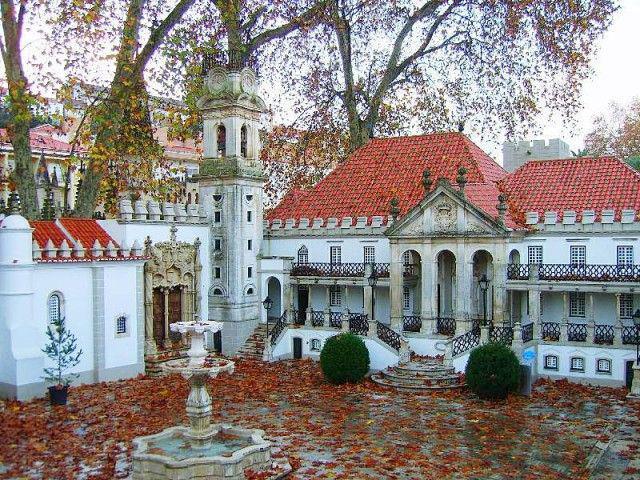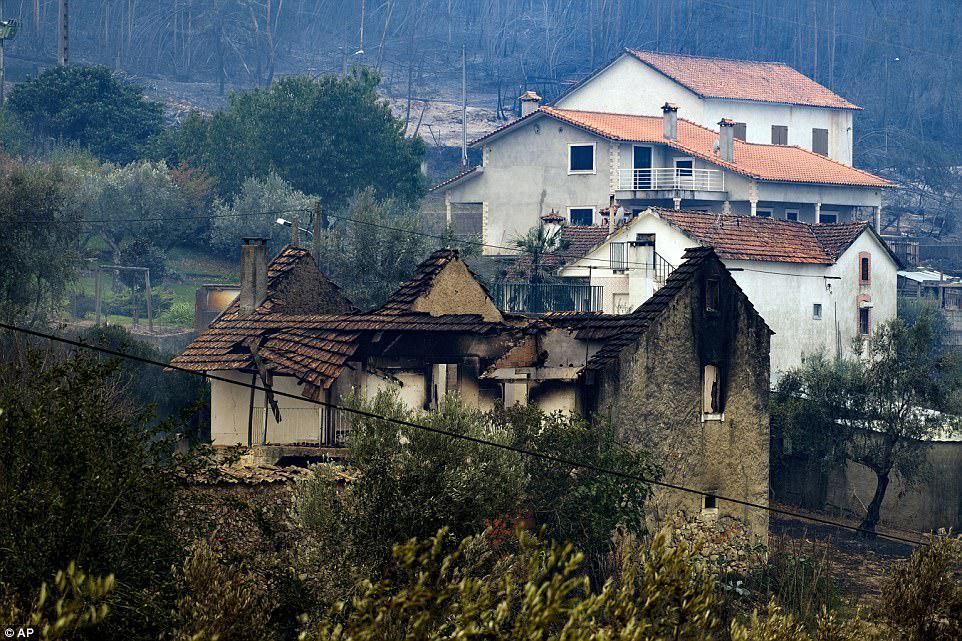The first image is the image on the left, the second image is the image on the right. For the images shown, is this caption "The right image includes rustic curving walls made of stones of varying shapes." true? Answer yes or no. No. The first image is the image on the left, the second image is the image on the right. Given the left and right images, does the statement "There are chairs outside." hold true? Answer yes or no. No. 